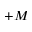Convert formula to latex. <formula><loc_0><loc_0><loc_500><loc_500>+ M</formula> 